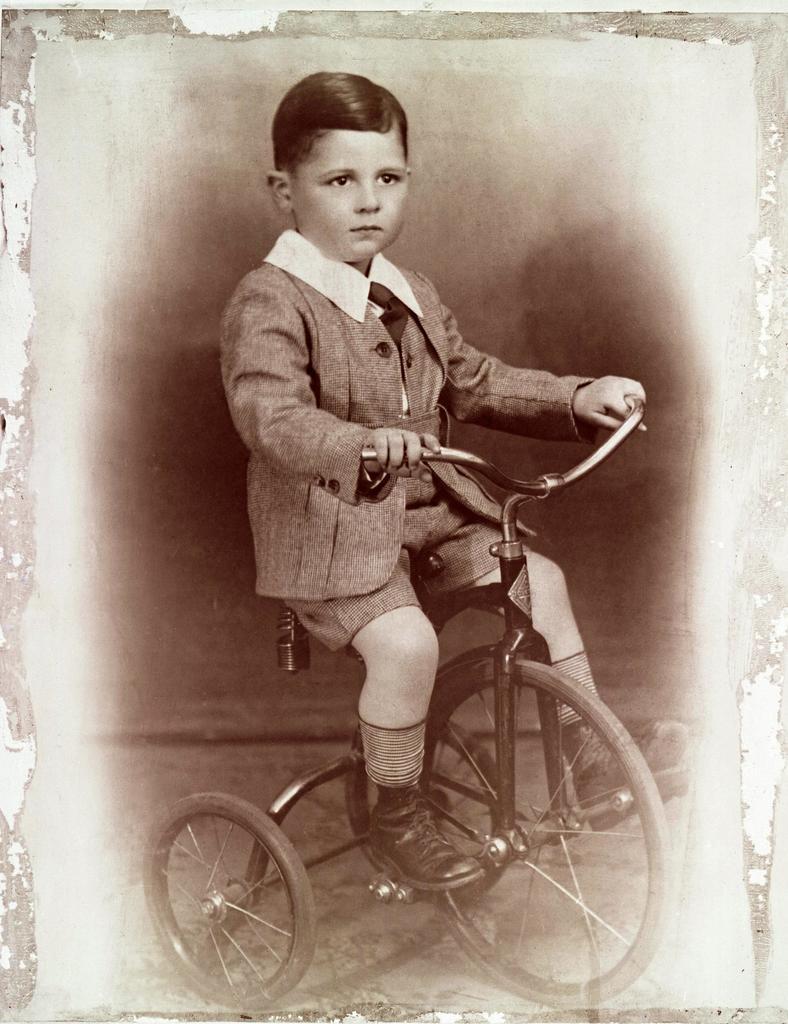How would you summarize this image in a sentence or two? In the image we can see there is a man who is sitting on a bicycle and the image is in black and white colour. 